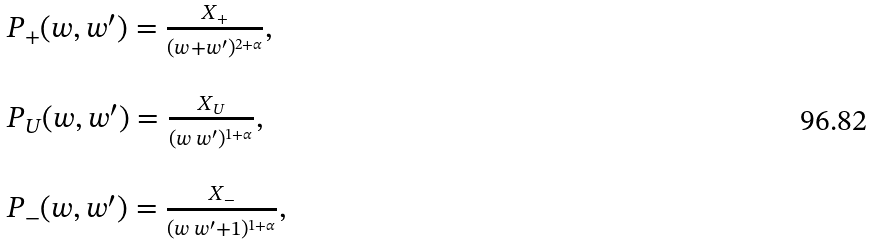<formula> <loc_0><loc_0><loc_500><loc_500>\begin{array} { l } P _ { + } ( w , w ^ { \prime } ) = \frac { X _ { + } } { ( w + w ^ { \prime } ) ^ { 2 + \alpha } } , \\ \, \\ P _ { U } ( w , w ^ { \prime } ) = \frac { X _ { U } } { ( w \, w ^ { \prime } ) ^ { 1 + \alpha } } , \\ \, \\ P _ { - } ( w , w ^ { \prime } ) = \frac { X _ { - } } { ( w \, w ^ { \prime } + 1 ) ^ { 1 + \alpha } } , \end{array}</formula> 